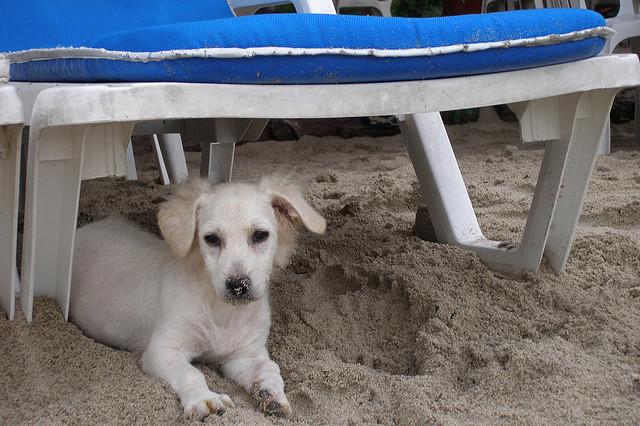Is the dog playing with the frisbee?
Quick response, please. No. How aggressive can these dogs get?
Short answer required. Not very. What is the color of the dog?
Keep it brief. White. Where are the puppies?
Quick response, please. Under chair. What is on the puppy's nose?
Short answer required. Sand. What breed of dog is that?
Short answer required. Terrier. Where is the dog lying?
Write a very short answer. Under chair. What kind of dog is here?
Quick response, please. Puppy. What has the puppy been doing?
Concise answer only. Digging. What does the dog have in its mouth?
Write a very short answer. Nothing. 